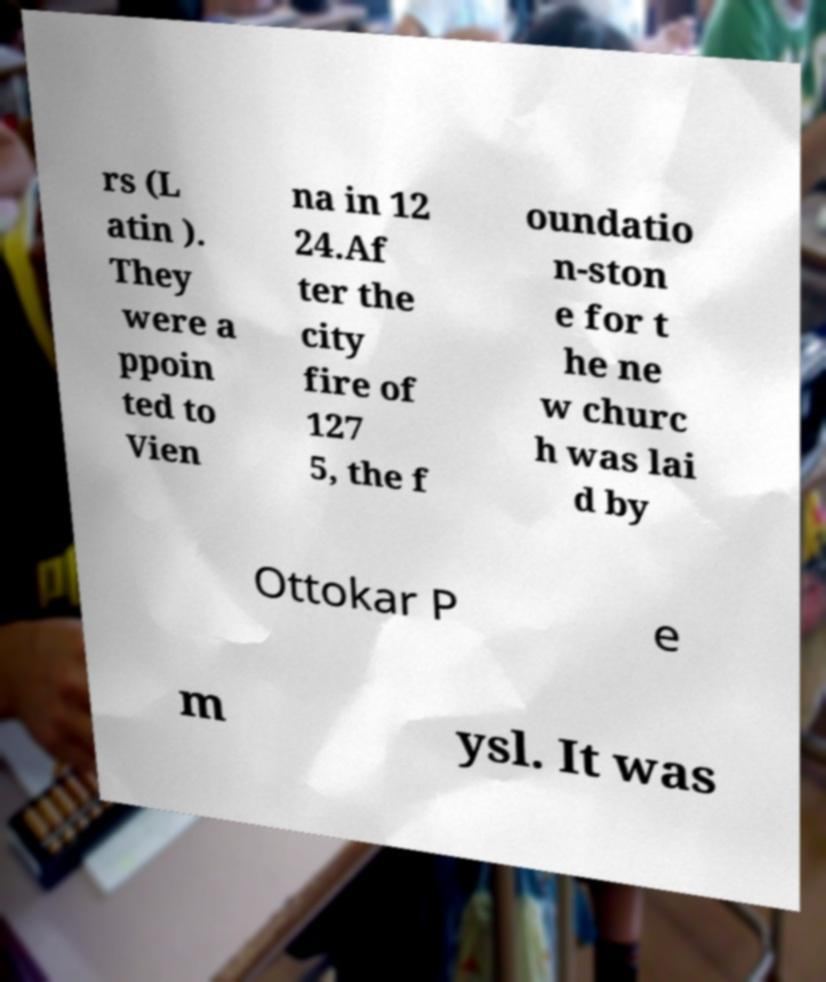There's text embedded in this image that I need extracted. Can you transcribe it verbatim? rs (L atin ). They were a ppoin ted to Vien na in 12 24.Af ter the city fire of 127 5, the f oundatio n-ston e for t he ne w churc h was lai d by Ottokar P e m ysl. It was 